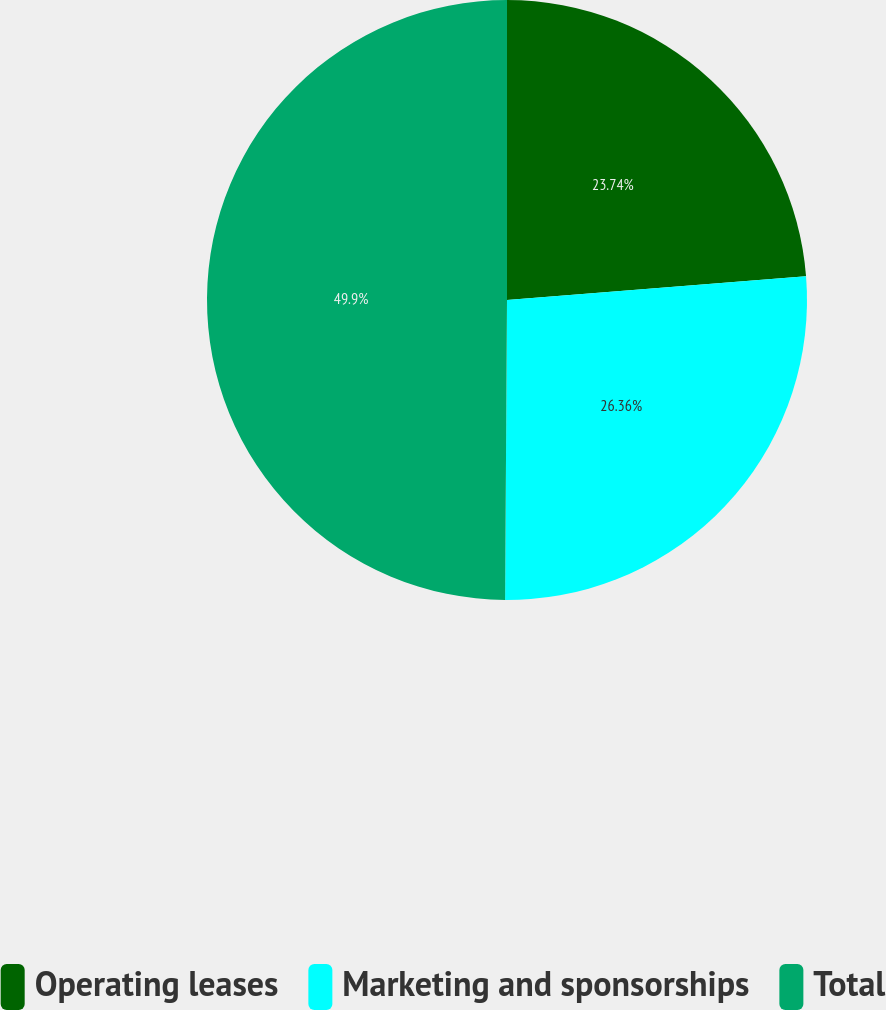Convert chart to OTSL. <chart><loc_0><loc_0><loc_500><loc_500><pie_chart><fcel>Operating leases<fcel>Marketing and sponsorships<fcel>Total<nl><fcel>23.74%<fcel>26.36%<fcel>49.9%<nl></chart> 